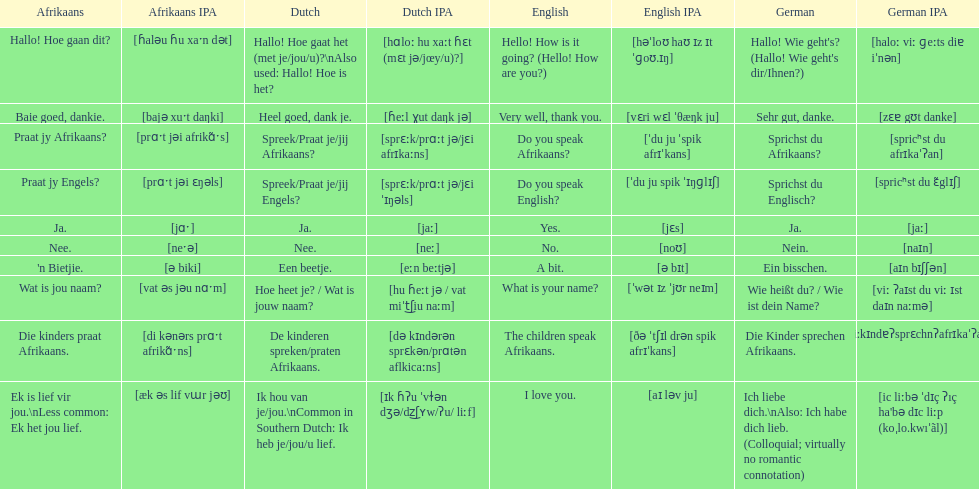How do you say hello! how is it going? in afrikaans? Hallo! Hoe gaan dit?. How do you say very well, thank you in afrikaans? Baie goed, dankie. How would you say do you speak afrikaans? in afrikaans? Praat jy Afrikaans?. 